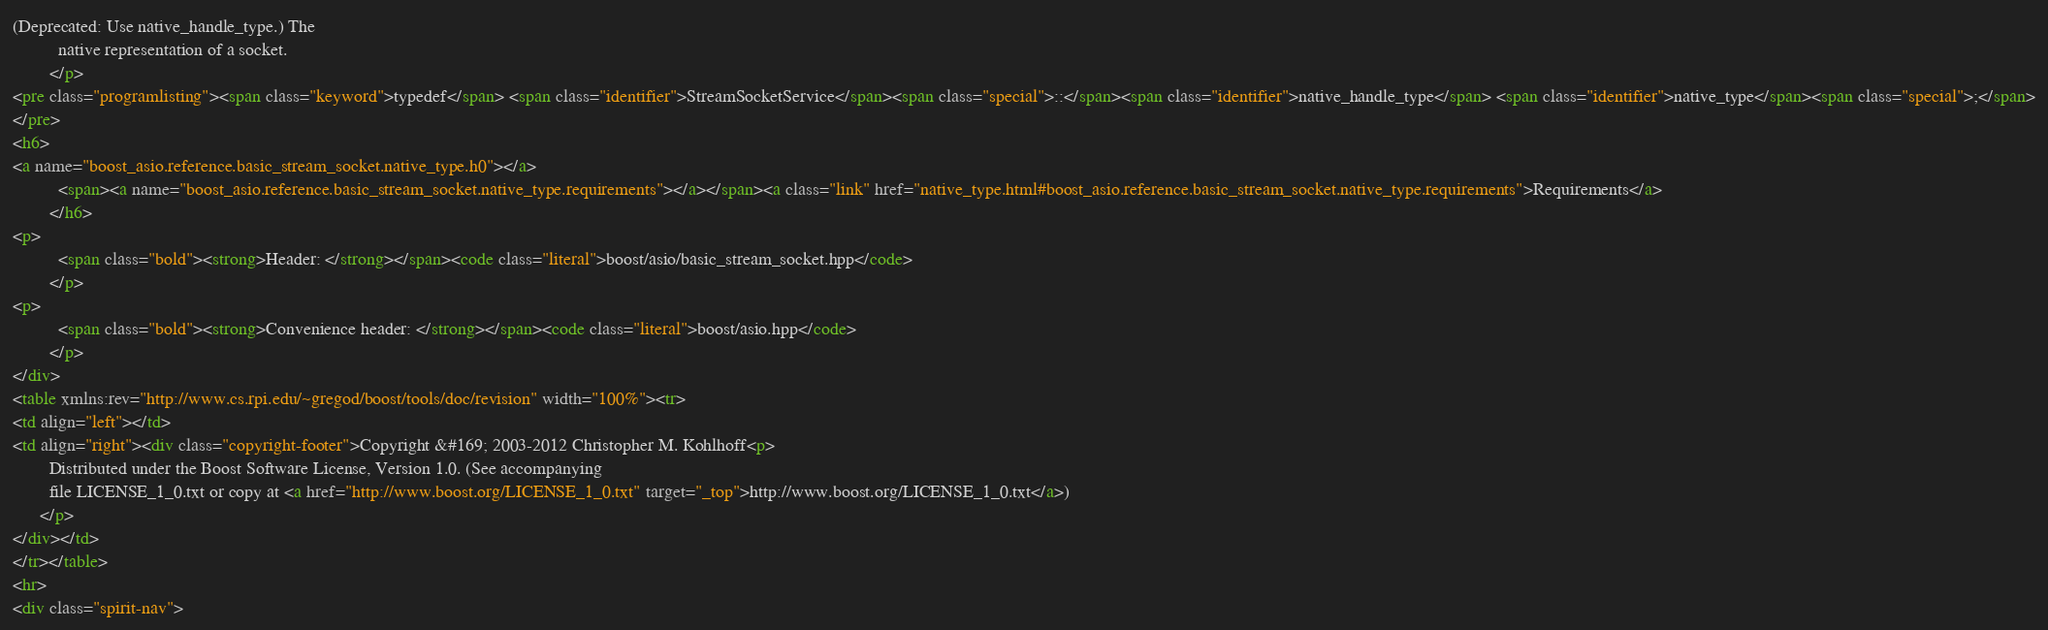<code> <loc_0><loc_0><loc_500><loc_500><_HTML_>(Deprecated: Use native_handle_type.) The
          native representation of a socket.
        </p>
<pre class="programlisting"><span class="keyword">typedef</span> <span class="identifier">StreamSocketService</span><span class="special">::</span><span class="identifier">native_handle_type</span> <span class="identifier">native_type</span><span class="special">;</span>
</pre>
<h6>
<a name="boost_asio.reference.basic_stream_socket.native_type.h0"></a>
          <span><a name="boost_asio.reference.basic_stream_socket.native_type.requirements"></a></span><a class="link" href="native_type.html#boost_asio.reference.basic_stream_socket.native_type.requirements">Requirements</a>
        </h6>
<p>
          <span class="bold"><strong>Header: </strong></span><code class="literal">boost/asio/basic_stream_socket.hpp</code>
        </p>
<p>
          <span class="bold"><strong>Convenience header: </strong></span><code class="literal">boost/asio.hpp</code>
        </p>
</div>
<table xmlns:rev="http://www.cs.rpi.edu/~gregod/boost/tools/doc/revision" width="100%"><tr>
<td align="left"></td>
<td align="right"><div class="copyright-footer">Copyright &#169; 2003-2012 Christopher M. Kohlhoff<p>
        Distributed under the Boost Software License, Version 1.0. (See accompanying
        file LICENSE_1_0.txt or copy at <a href="http://www.boost.org/LICENSE_1_0.txt" target="_top">http://www.boost.org/LICENSE_1_0.txt</a>)
      </p>
</div></td>
</tr></table>
<hr>
<div class="spirit-nav"></code> 